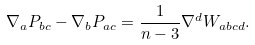<formula> <loc_0><loc_0><loc_500><loc_500>\nabla _ { a } P _ { b c } - \nabla _ { b } P _ { a c } = \frac { 1 } { n - 3 } \nabla ^ { d } W _ { a b c d } .</formula> 